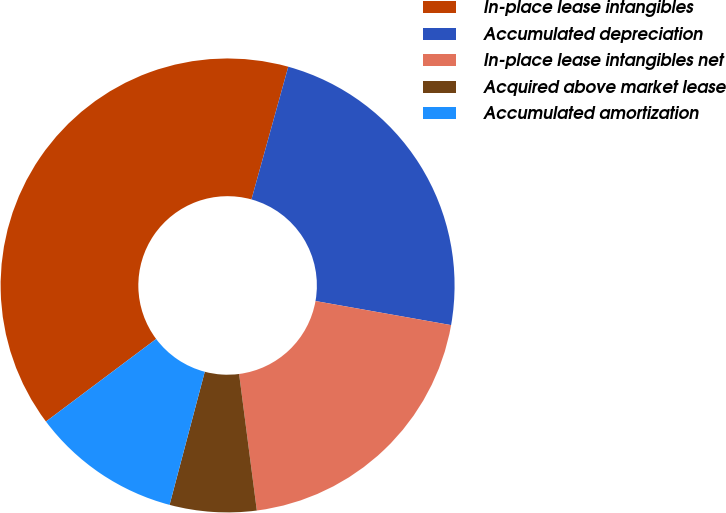Convert chart to OTSL. <chart><loc_0><loc_0><loc_500><loc_500><pie_chart><fcel>In-place lease intangibles<fcel>Accumulated depreciation<fcel>In-place lease intangibles net<fcel>Acquired above market lease<fcel>Accumulated amortization<nl><fcel>39.54%<fcel>23.49%<fcel>20.15%<fcel>6.17%<fcel>10.65%<nl></chart> 